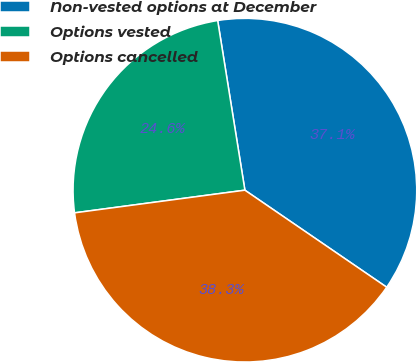Convert chart to OTSL. <chart><loc_0><loc_0><loc_500><loc_500><pie_chart><fcel>Non-vested options at December<fcel>Options vested<fcel>Options cancelled<nl><fcel>37.08%<fcel>24.57%<fcel>38.34%<nl></chart> 